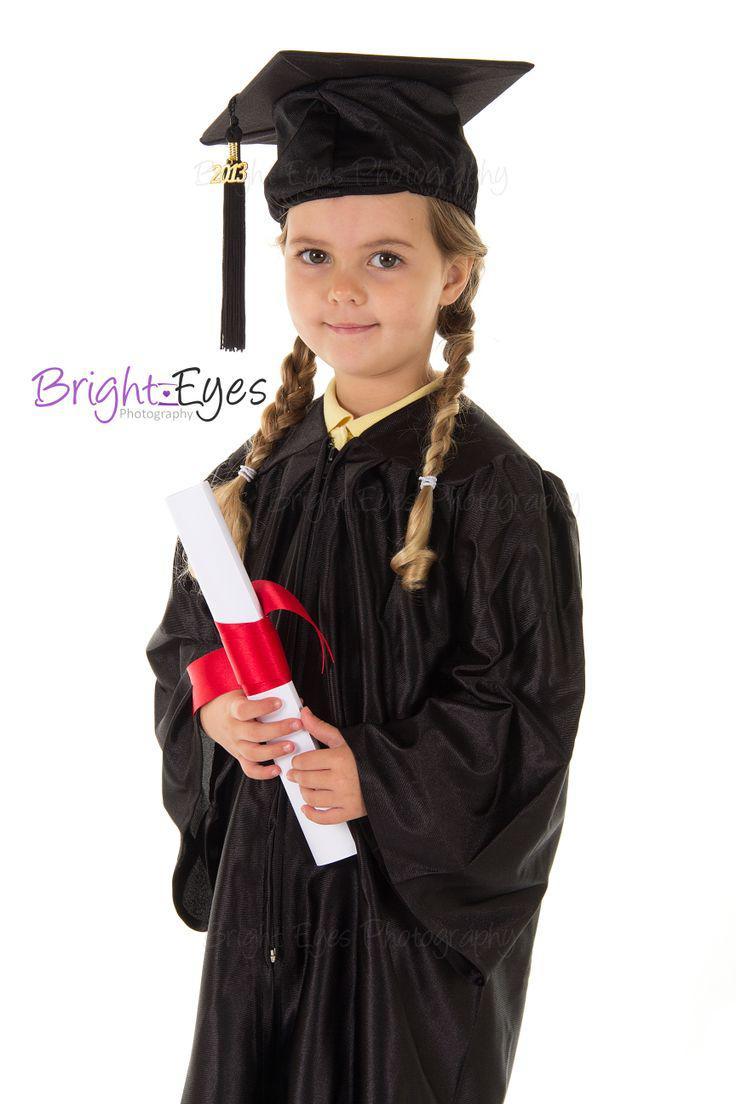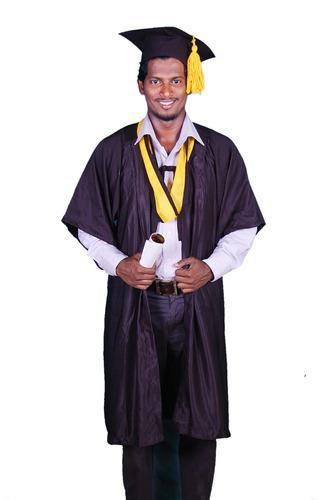The first image is the image on the left, the second image is the image on the right. Assess this claim about the two images: "In one of the images there are a pair of students wearing a graduation cap and gown.". Correct or not? Answer yes or no. No. The first image is the image on the left, the second image is the image on the right. Analyze the images presented: Is the assertion "In each set there are two children in black graduation gowns and caps and one has a yellow collar and one has a red collar." valid? Answer yes or no. No. 